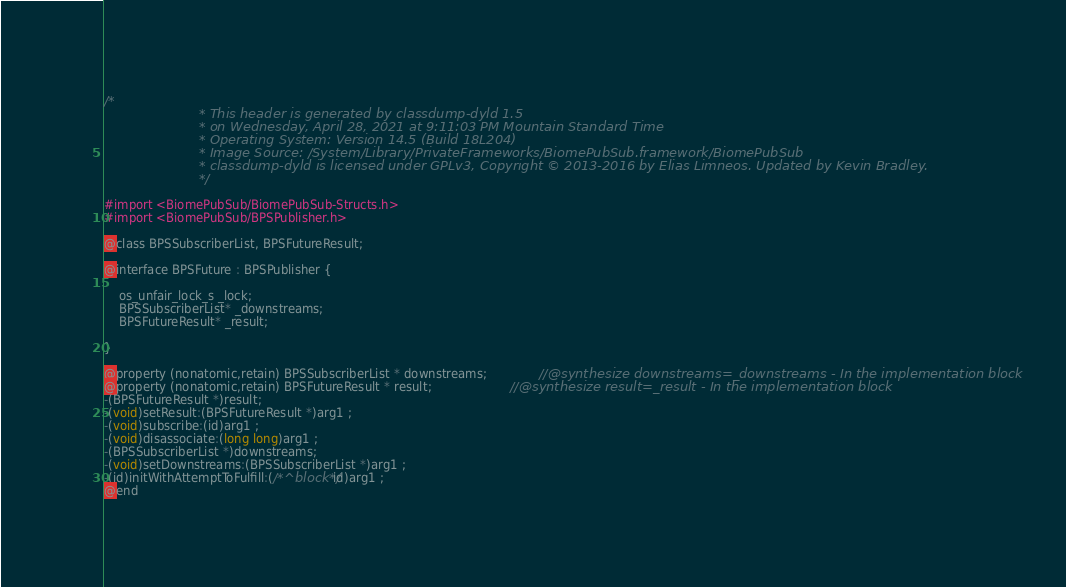Convert code to text. <code><loc_0><loc_0><loc_500><loc_500><_C_>/*
                       * This header is generated by classdump-dyld 1.5
                       * on Wednesday, April 28, 2021 at 9:11:03 PM Mountain Standard Time
                       * Operating System: Version 14.5 (Build 18L204)
                       * Image Source: /System/Library/PrivateFrameworks/BiomePubSub.framework/BiomePubSub
                       * classdump-dyld is licensed under GPLv3, Copyright © 2013-2016 by Elias Limneos. Updated by Kevin Bradley.
                       */

#import <BiomePubSub/BiomePubSub-Structs.h>
#import <BiomePubSub/BPSPublisher.h>

@class BPSSubscriberList, BPSFutureResult;

@interface BPSFuture : BPSPublisher {

	os_unfair_lock_s _lock;
	BPSSubscriberList* _downstreams;
	BPSFutureResult* _result;

}

@property (nonatomic,retain) BPSSubscriberList * downstreams;              //@synthesize downstreams=_downstreams - In the implementation block
@property (nonatomic,retain) BPSFutureResult * result;                     //@synthesize result=_result - In the implementation block
-(BPSFutureResult *)result;
-(void)setResult:(BPSFutureResult *)arg1 ;
-(void)subscribe:(id)arg1 ;
-(void)disassociate:(long long)arg1 ;
-(BPSSubscriberList *)downstreams;
-(void)setDownstreams:(BPSSubscriberList *)arg1 ;
-(id)initWithAttemptToFulfill:(/*^block*/id)arg1 ;
@end

</code> 